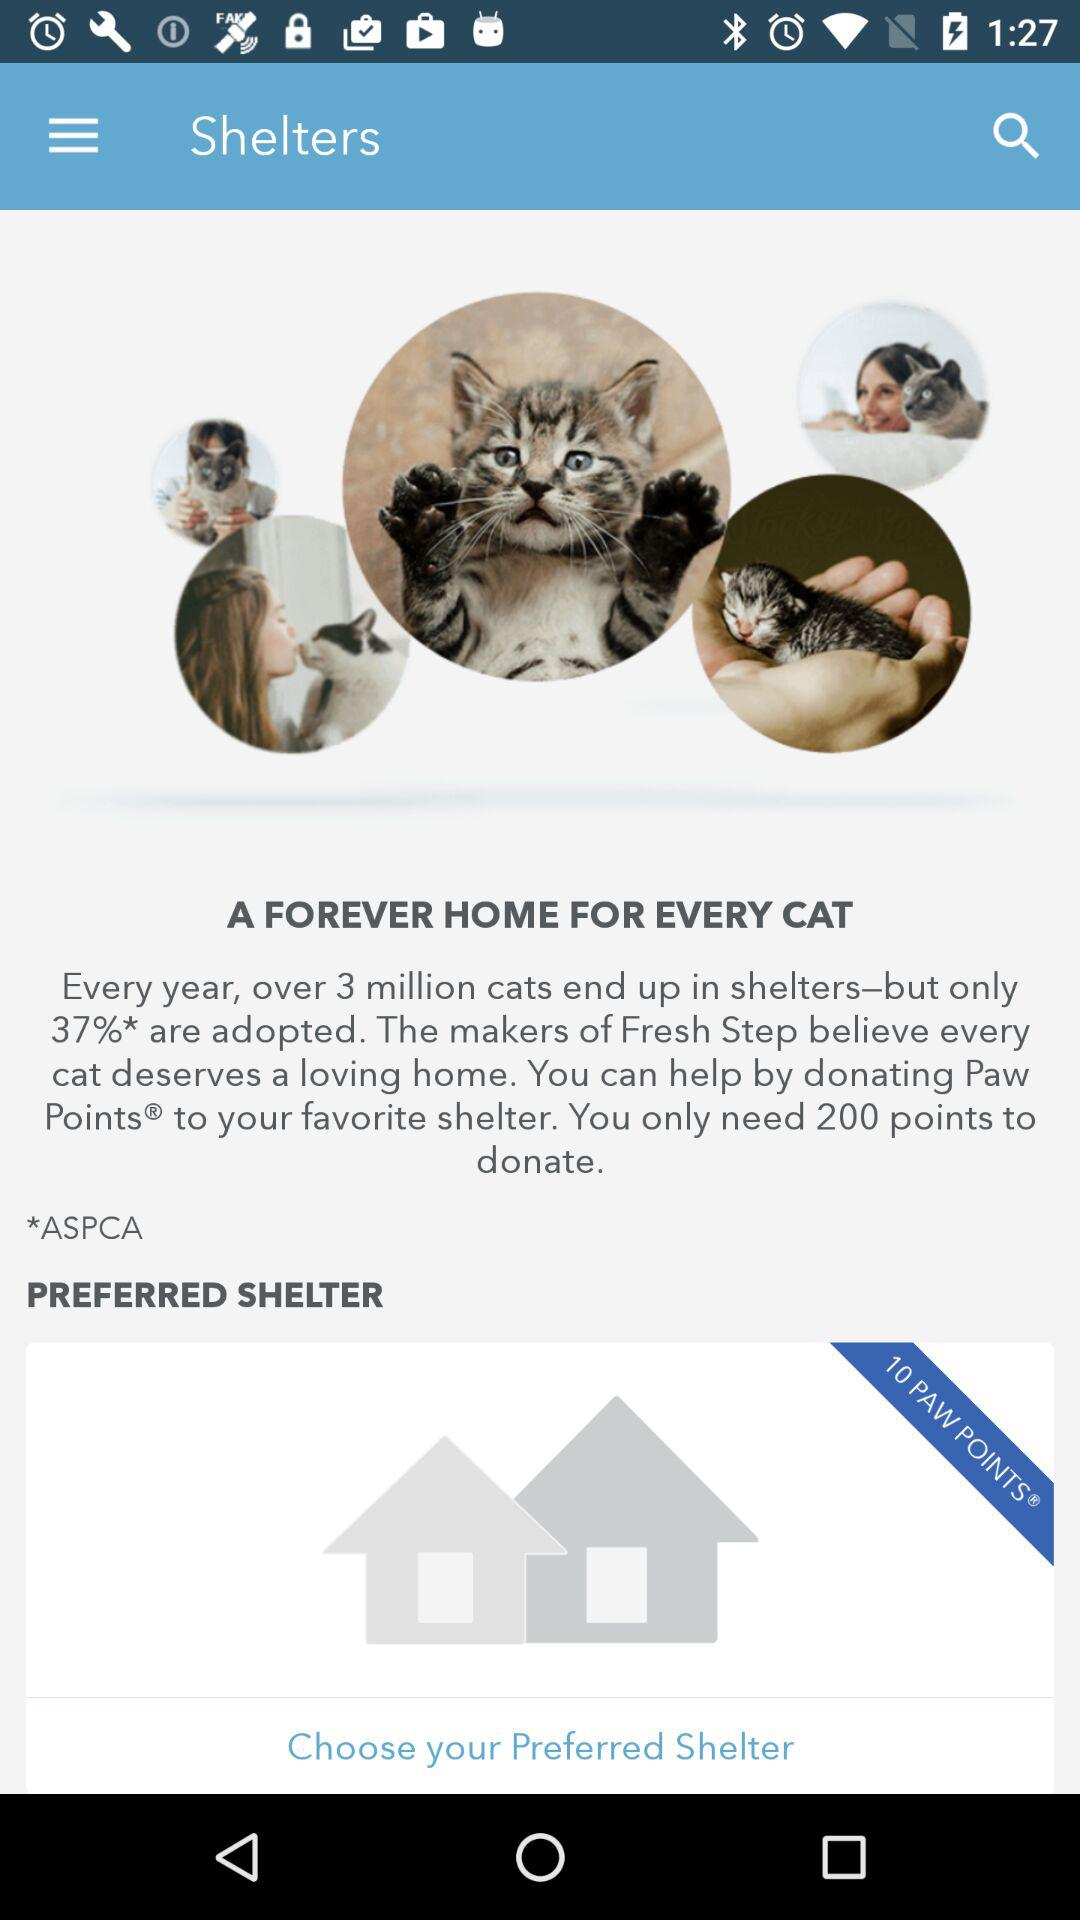How many points do I need to donate?
Answer the question using a single word or phrase. 200 